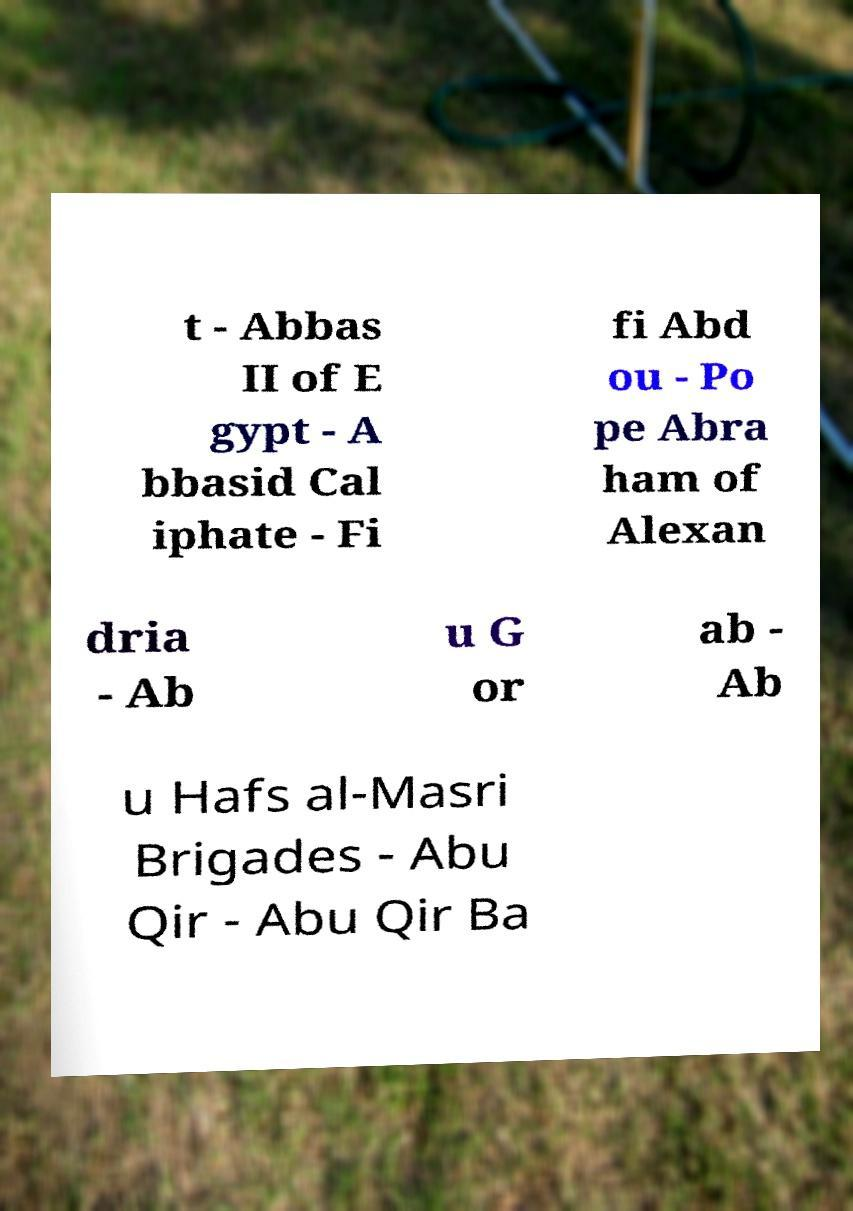Please identify and transcribe the text found in this image. t - Abbas II of E gypt - A bbasid Cal iphate - Fi fi Abd ou - Po pe Abra ham of Alexan dria - Ab u G or ab - Ab u Hafs al-Masri Brigades - Abu Qir - Abu Qir Ba 